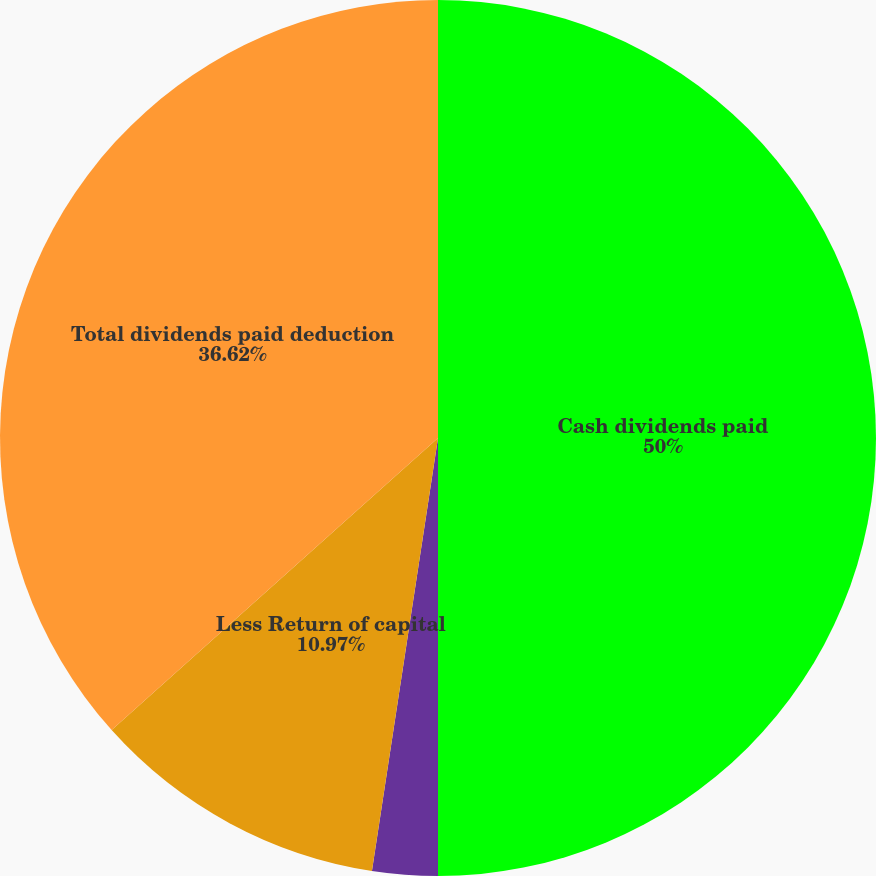<chart> <loc_0><loc_0><loc_500><loc_500><pie_chart><fcel>Cash dividends paid<fcel>Less Capital gain<fcel>Less Return of capital<fcel>Total dividends paid deduction<nl><fcel>50.0%<fcel>2.41%<fcel>10.97%<fcel>36.62%<nl></chart> 